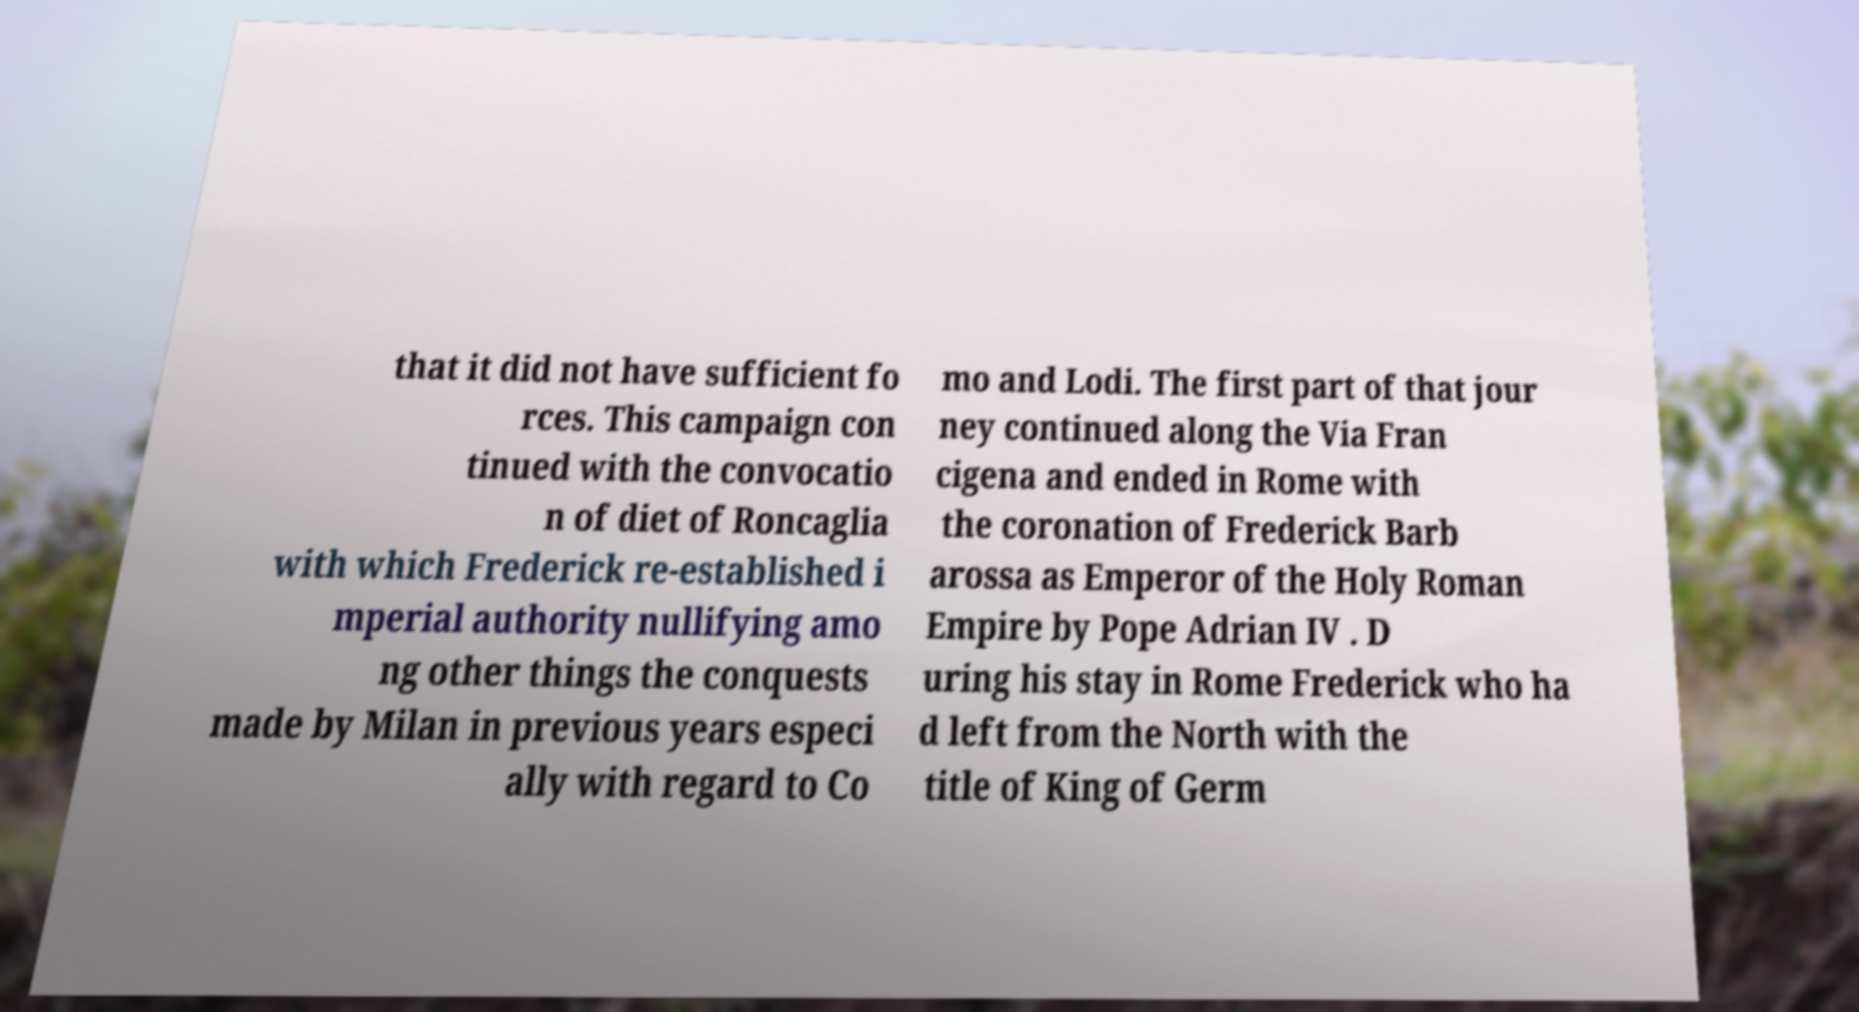Could you extract and type out the text from this image? that it did not have sufficient fo rces. This campaign con tinued with the convocatio n of diet of Roncaglia with which Frederick re-established i mperial authority nullifying amo ng other things the conquests made by Milan in previous years especi ally with regard to Co mo and Lodi. The first part of that jour ney continued along the Via Fran cigena and ended in Rome with the coronation of Frederick Barb arossa as Emperor of the Holy Roman Empire by Pope Adrian IV . D uring his stay in Rome Frederick who ha d left from the North with the title of King of Germ 